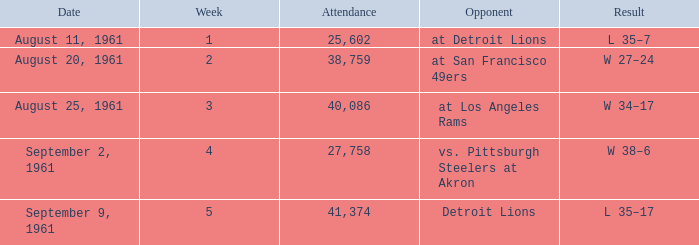What was the score of the Browns week 4 game? W 38–6. 